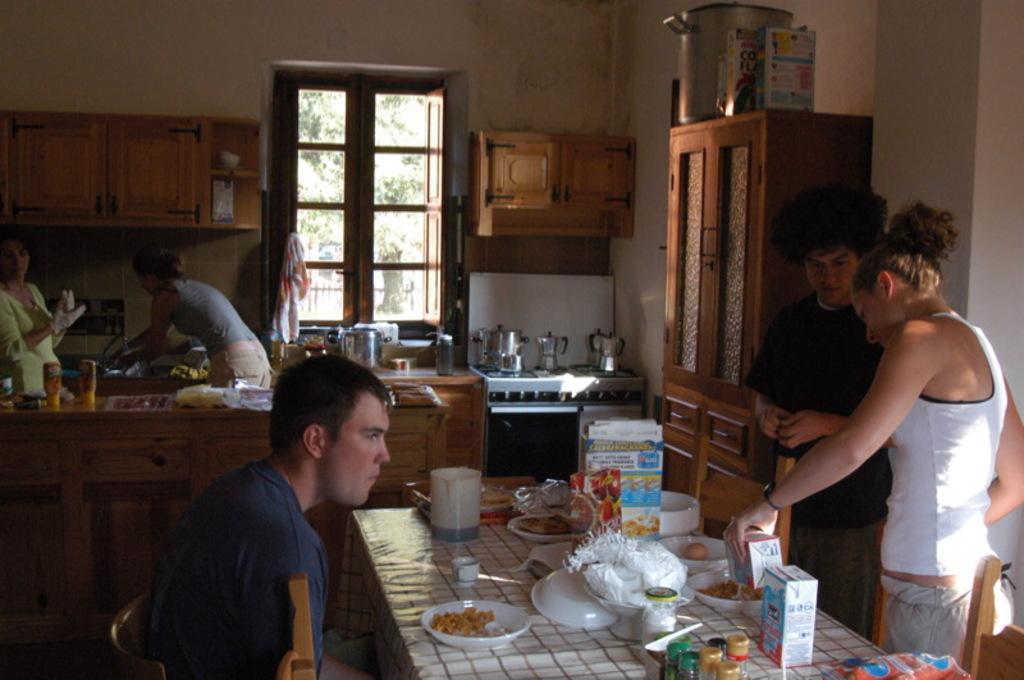Please provide a concise description of this image. This is a picture of a kitchen where we can see some people and a table on which there are some food items and chairs and also the other desk on which we have the kitchen items and a shelf on which a container is placed and a window. 